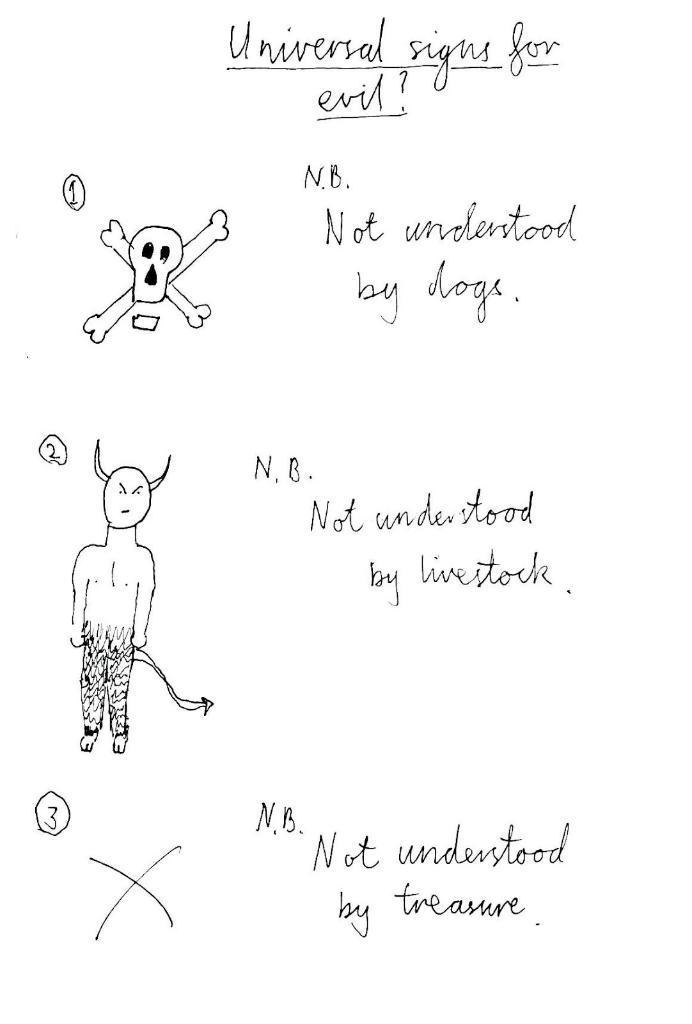Can you describe this image briefly? This is a page,on this page we can see symbols and text. 